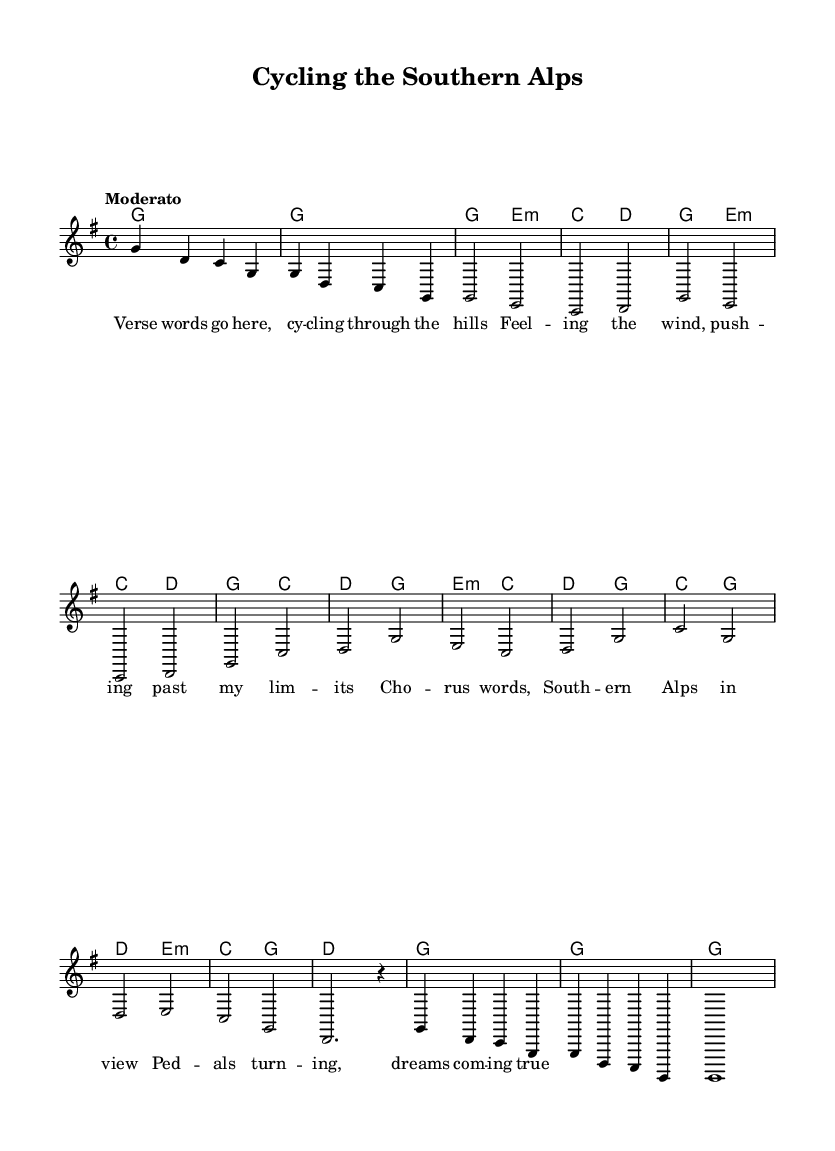What is the key signature of this music? The key signature is G major, which has one sharp (F#). This can be determined by checking the key signature indicated at the beginning of the score.
Answer: G major What is the time signature? The time signature is 4/4, visible at the start of the score, indicating four beats per measure. Each measure contains four quarter notes or equivalent notes.
Answer: 4/4 What is the tempo marking given? The tempo marking is "Moderato," indicated in the score. This typically suggests a moderate speed, which instructs the performer on how quickly to play the piece.
Answer: Moderato How many measures are in the verse section? The verse section contains 8 measures. By counting the measures in the verse part of the score, we see there are four sets of two measures each.
Answer: 8 What chords are used in the chorus? The chords used in the chorus are G, C, D, and Em as indicated by the chord symbols above the melody lines in the chorus section of the music.
Answer: G, C, D, Em What emotions are conveyed in the lyrics? The lyrics convey a sense of freedom and determination as they describe cycling through the scenic beauty of the Southern Alps, expressing the joy of pedaling and pursuit of dreams.
Answer: Freedom and determination What is the structure of the piece? The structure of the piece follows a typical song format: Intro, Verse, Chorus, Bridge, and Outro as seen in the layout of melody and harmony sections in the score.
Answer: Intro, Verse, Chorus, Bridge, Outro 